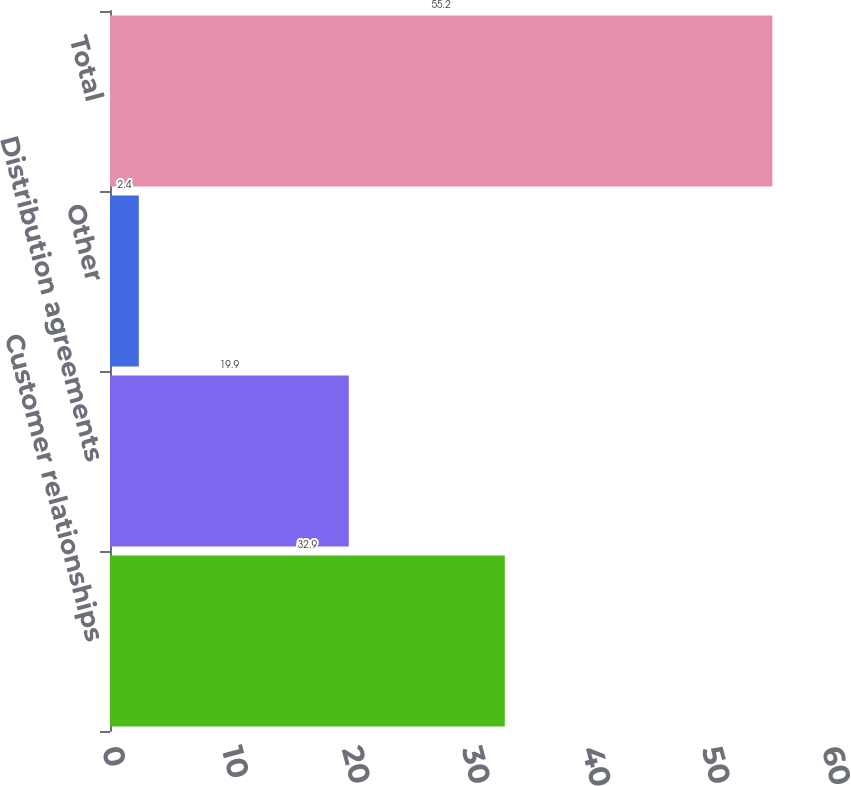Convert chart to OTSL. <chart><loc_0><loc_0><loc_500><loc_500><bar_chart><fcel>Customer relationships<fcel>Distribution agreements<fcel>Other<fcel>Total<nl><fcel>32.9<fcel>19.9<fcel>2.4<fcel>55.2<nl></chart> 